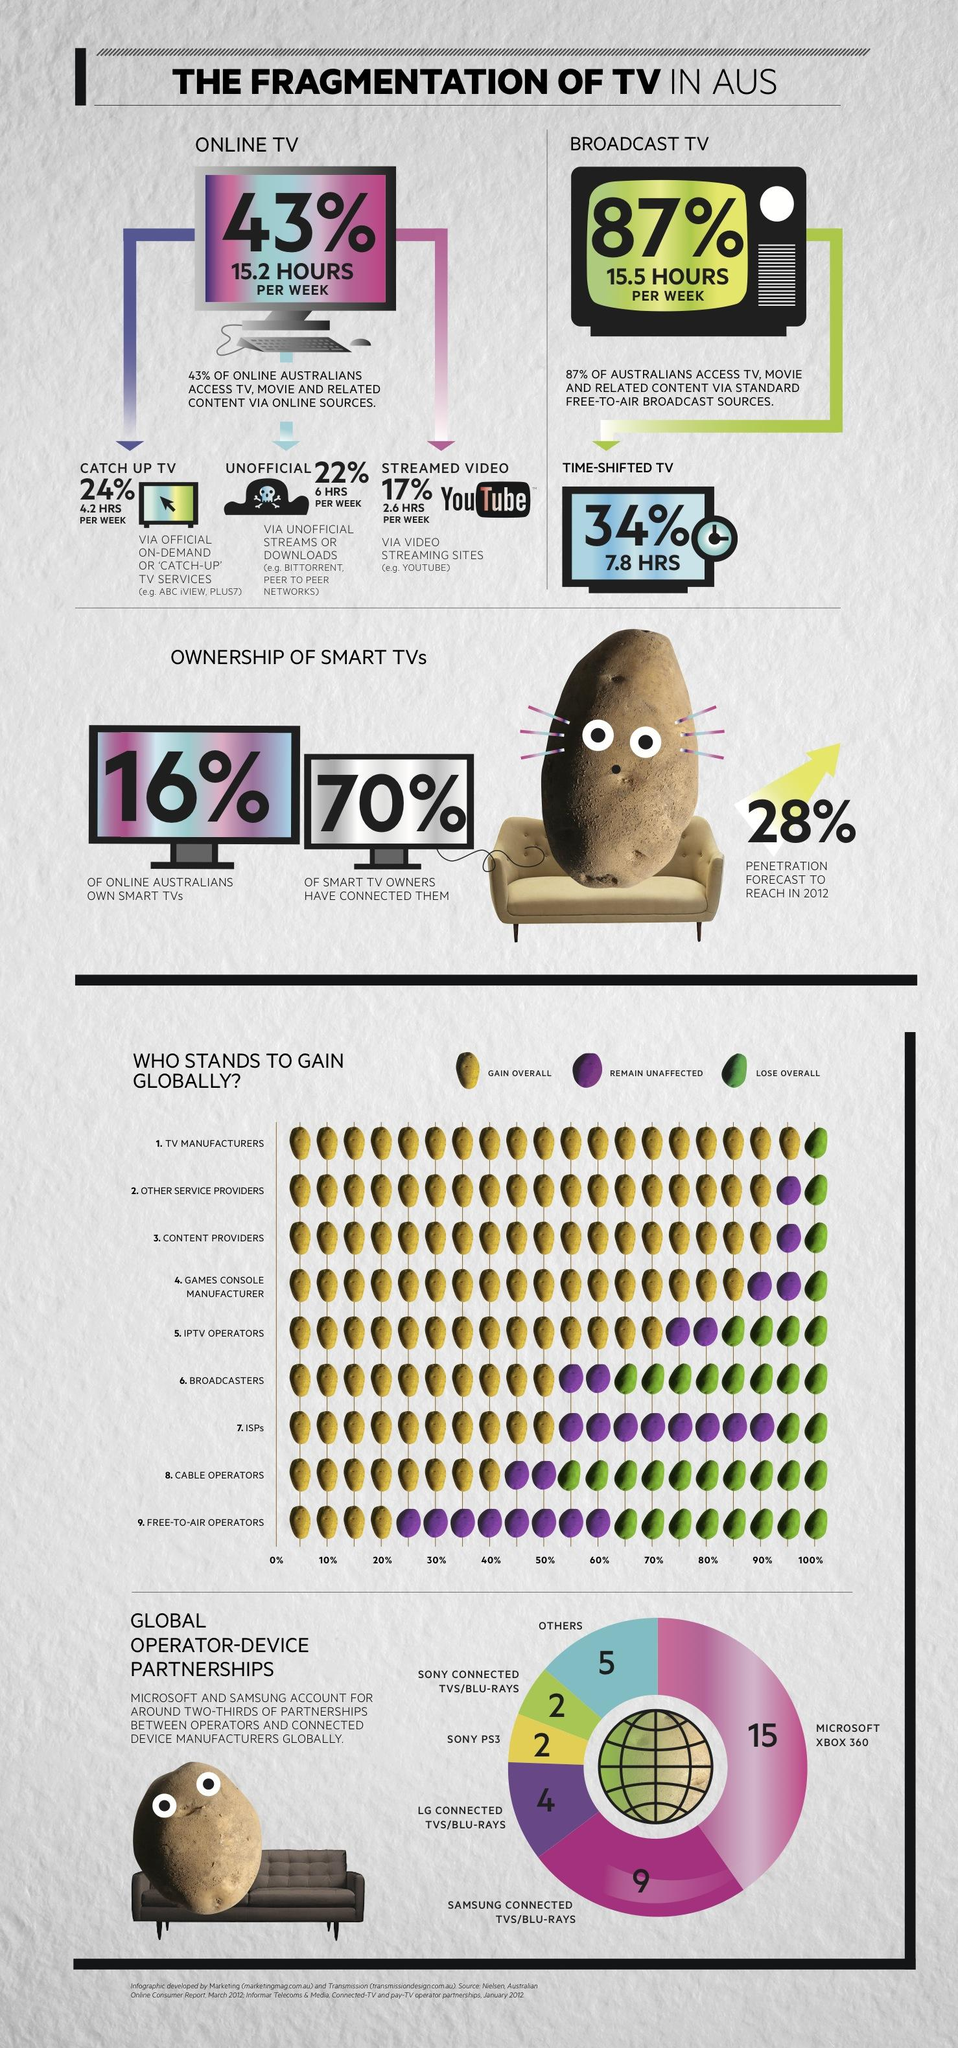Outline some significant characteristics in this image. Broadcast TV has more access hours per week than online TV. The overall loss for broadcasters is approximately 40%. It is anticipated that ISPs, who currently only lose 10% of their customers, will continue to experience minimal losses despite the shift towards IPv6 and the potential for increased competition. It can be declared that free-to-air operators are the ones who gain the least overall. The overall gain for TV manufacturers is 95%. 